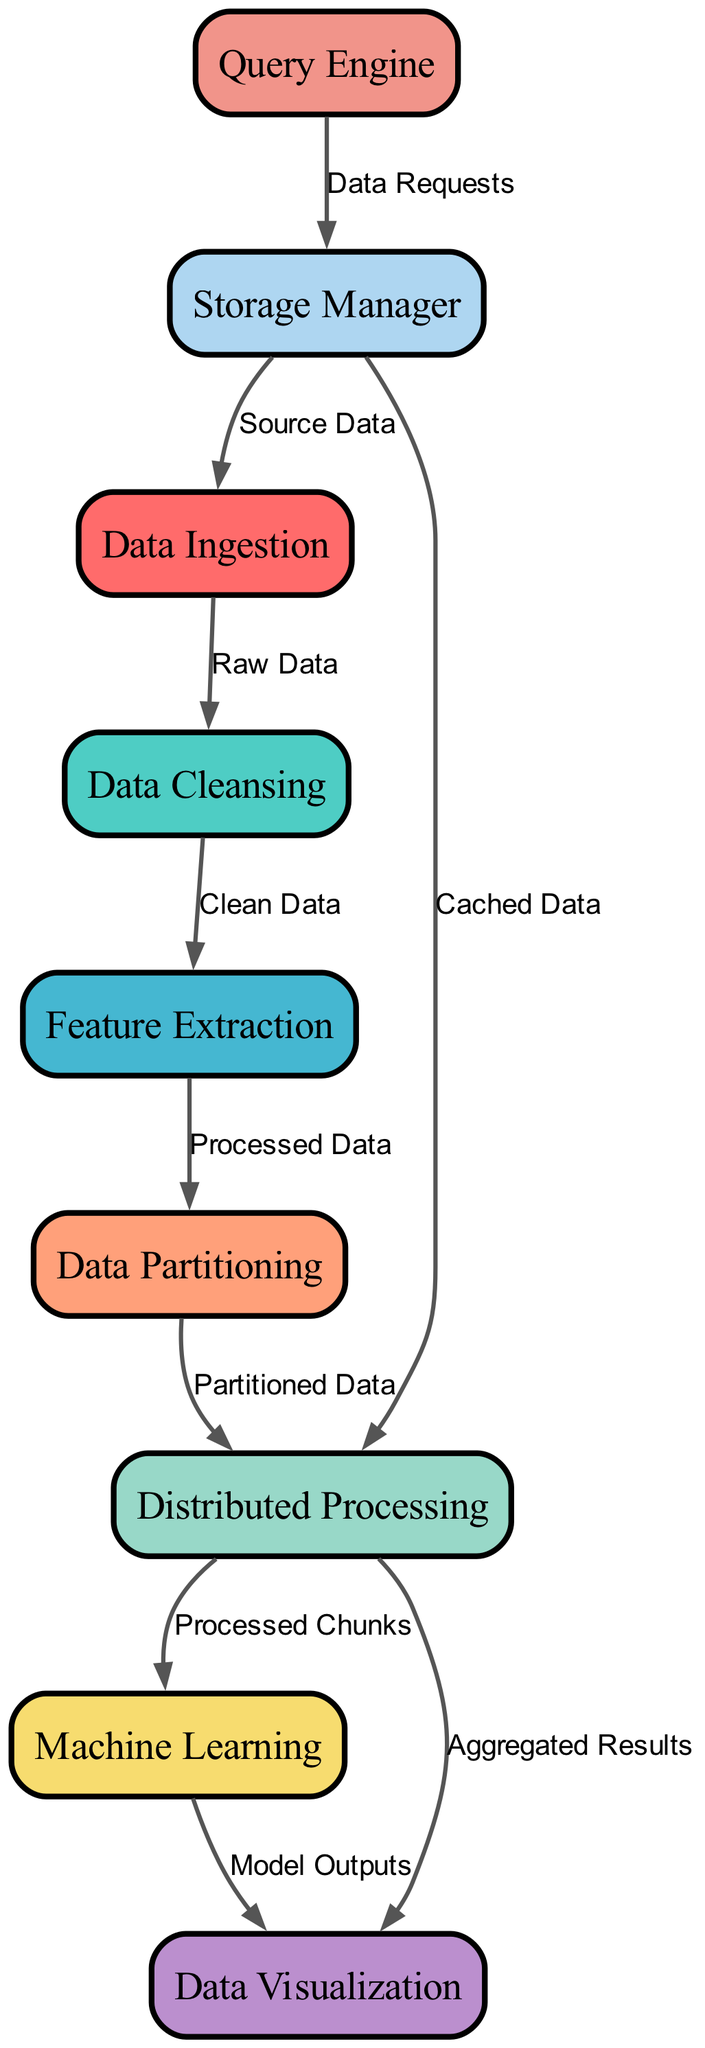What is the first module in the dependency graph? The first module is identified as "Data Ingestion," which is the starting point of the data processing flow in the diagram.
Answer: Data Ingestion How many nodes are present in the diagram? By counting the modules listed in the data section, there are nine distinct nodes shown in the diagram.
Answer: 9 What type of data does "Data Ingestion" output to "Data Cleansing"? The label on the edge connecting "Data Ingestion" to "Data Cleansing" indicates that the type of data is "Raw Data."
Answer: Raw Data Which module directly receives data from "Distributed Processing"? "Machine Learning" and "Data Visualization" both receive data from "Distributed Processing," but "Machine Learning" is identified first in the flow.
Answer: Machine Learning What relationship exists between "Storage Manager" and "Data Ingestion"? The edge from "Storage Manager" to "Data Ingestion" indicates a flowing relationship where "Storage Manager" provides "Source Data" to "Data Ingestion."
Answer: Source Data What is the output from "Machine Learning" to "Data Visualization"? The label on the edge from "Machine Learning" to "Data Visualization" states that the output is "Model Outputs."
Answer: Model Outputs How does "Data Partitioning" support the "Distributed Processing" module? The edge from "Data Partitioning" to "Distributed Processing" shows that it provides "Partitioned Data," which is essential for distributed tasks.
Answer: Partitioned Data What is the role of "Query Engine" in the data processing flow? "Query Engine" sends "Data Requests" to "Storage Manager," indicating its function in managing queries within the data framework.
Answer: Data Requests Which module is the last step before data visualization? The flow indicates that the last processing step before data visualization is "Machine Learning," as it directly contributes outputs to the visualization module.
Answer: Machine Learning 